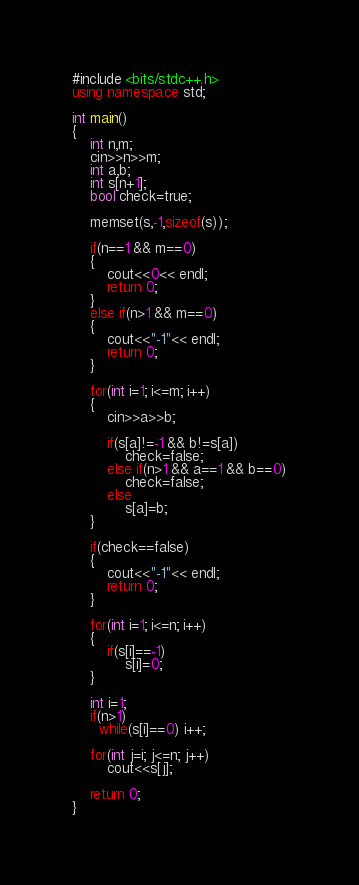Convert code to text. <code><loc_0><loc_0><loc_500><loc_500><_C++_>#include <bits/stdc++.h>
using namespace std;

int main()
{
	int n,m;
	cin>>n>>m;
	int a,b;
	int s[n+1];
	bool check=true;
	
	memset(s,-1,sizeof(s));
	
	if(n==1 && m==0)
	{
		cout<<0<< endl;
		return 0;
	}
	else if(n>1 && m==0)
	{
		cout<<"-1"<< endl;
		return 0;
	}
	
	for(int i=1; i<=m; i++)
	{
		cin>>a>>b;
		
		if(s[a]!=-1 && b!=s[a])
			check=false;
		else if(n>1 && a==1 && b==0)
			check=false;
		else
			s[a]=b;
	}
	
	if(check==false)
	{
		cout<<"-1"<< endl;
		return 0;
	}
	
	for(int i=1; i<=n; i++)
	{
		if(s[i]==-1)
			s[i]=0;
	}
	
	int i=1;
	if(n>1)
      while(s[i]==0) i++;
	
	for(int j=i; j<=n; j++)
		cout<<s[j];
	
	return 0;
}</code> 